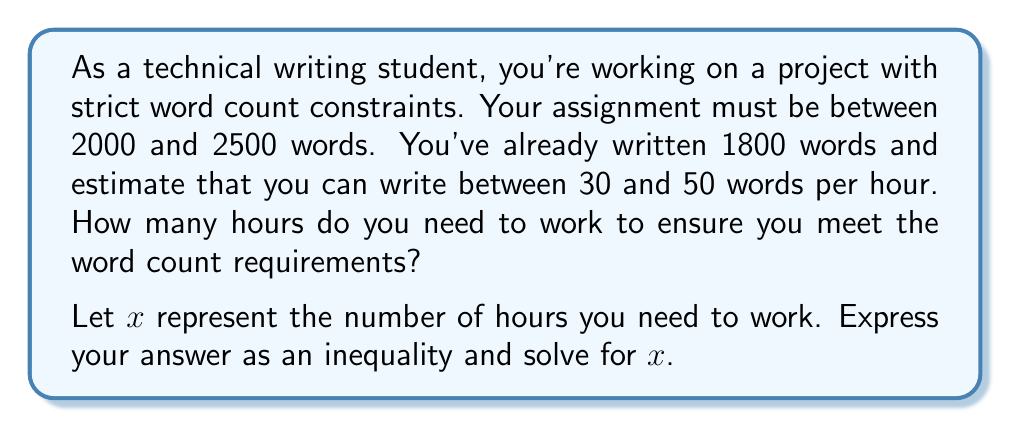What is the answer to this math problem? Let's approach this step-by-step:

1) First, let's set up our inequalities:
   
   Lower bound: $1800 + 30x \geq 2000$
   Upper bound: $1800 + 50x \leq 2500$

2) Let's solve the lower bound inequality:
   
   $1800 + 30x \geq 2000$
   $30x \geq 200$
   $x \geq \frac{200}{30} = \frac{20}{3} \approx 6.67$

3) Now, let's solve the upper bound inequality:
   
   $1800 + 50x \leq 2500$
   $50x \leq 700$
   $x \leq \frac{700}{50} = 14$

4) Combining these results, we get:

   $\frac{20}{3} \leq x \leq 14$

5) Since $x$ represents hours, which are typically expressed as whole numbers, we need to round up the lower bound and round down the upper bound:

   $7 \leq x \leq 14$

This means you need to work at least 7 hours to reach the minimum word count, and you can work up to 14 hours without exceeding the maximum word count.
Answer: $7 \leq x \leq 14$, where $x$ represents the number of hours you need to work. 